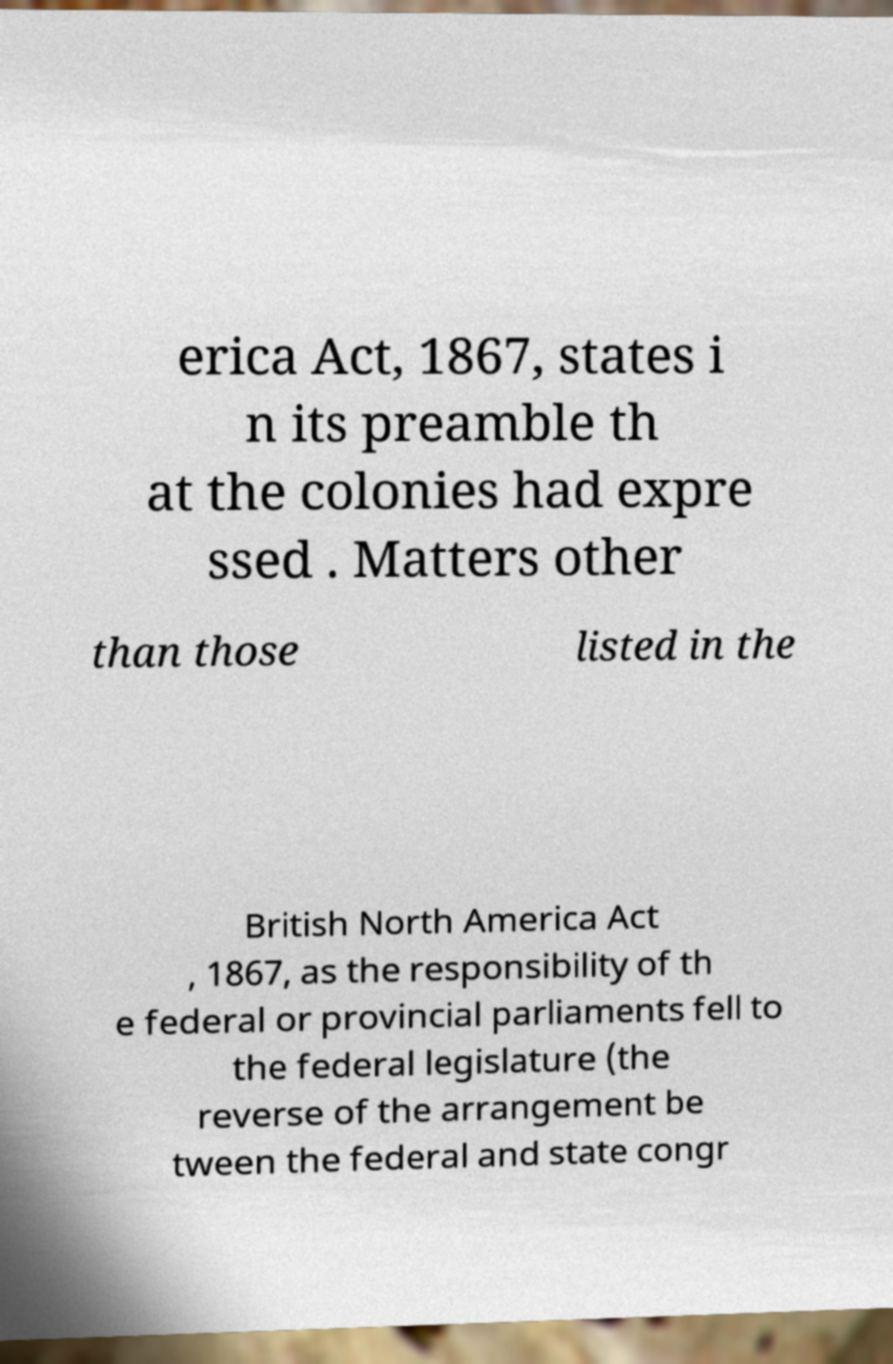Please identify and transcribe the text found in this image. erica Act, 1867, states i n its preamble th at the colonies had expre ssed . Matters other than those listed in the British North America Act , 1867, as the responsibility of th e federal or provincial parliaments fell to the federal legislature (the reverse of the arrangement be tween the federal and state congr 